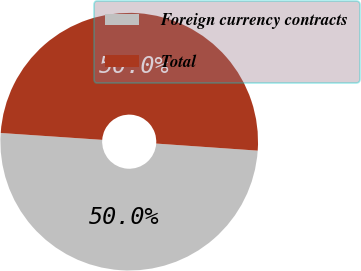<chart> <loc_0><loc_0><loc_500><loc_500><pie_chart><fcel>Foreign currency contracts<fcel>Total<nl><fcel>49.97%<fcel>50.03%<nl></chart> 